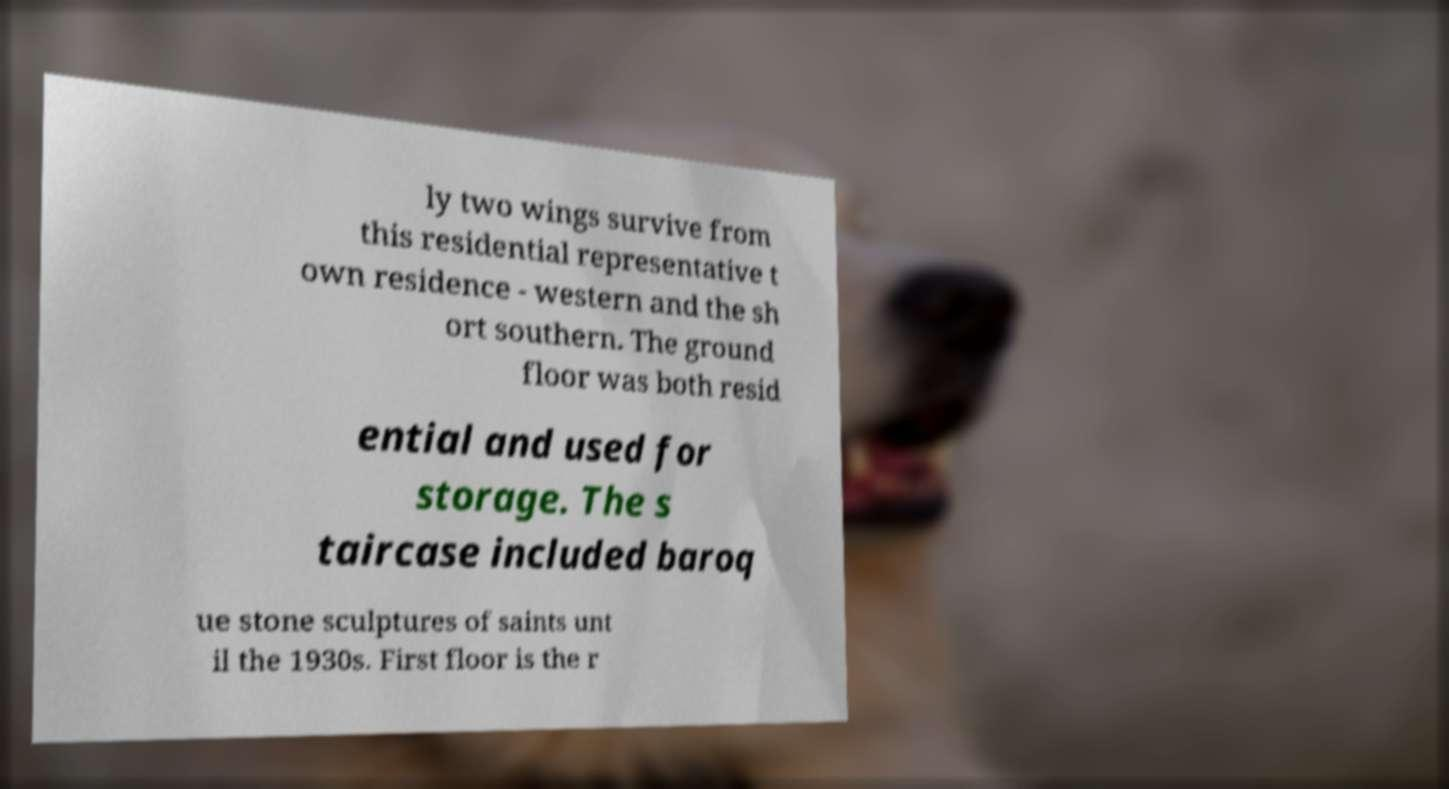Could you extract and type out the text from this image? ly two wings survive from this residential representative t own residence - western and the sh ort southern. The ground floor was both resid ential and used for storage. The s taircase included baroq ue stone sculptures of saints unt il the 1930s. First floor is the r 